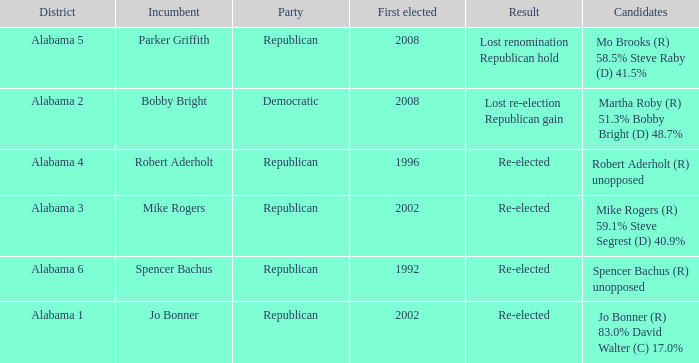Name the result for first elected being 1992 Re-elected. 